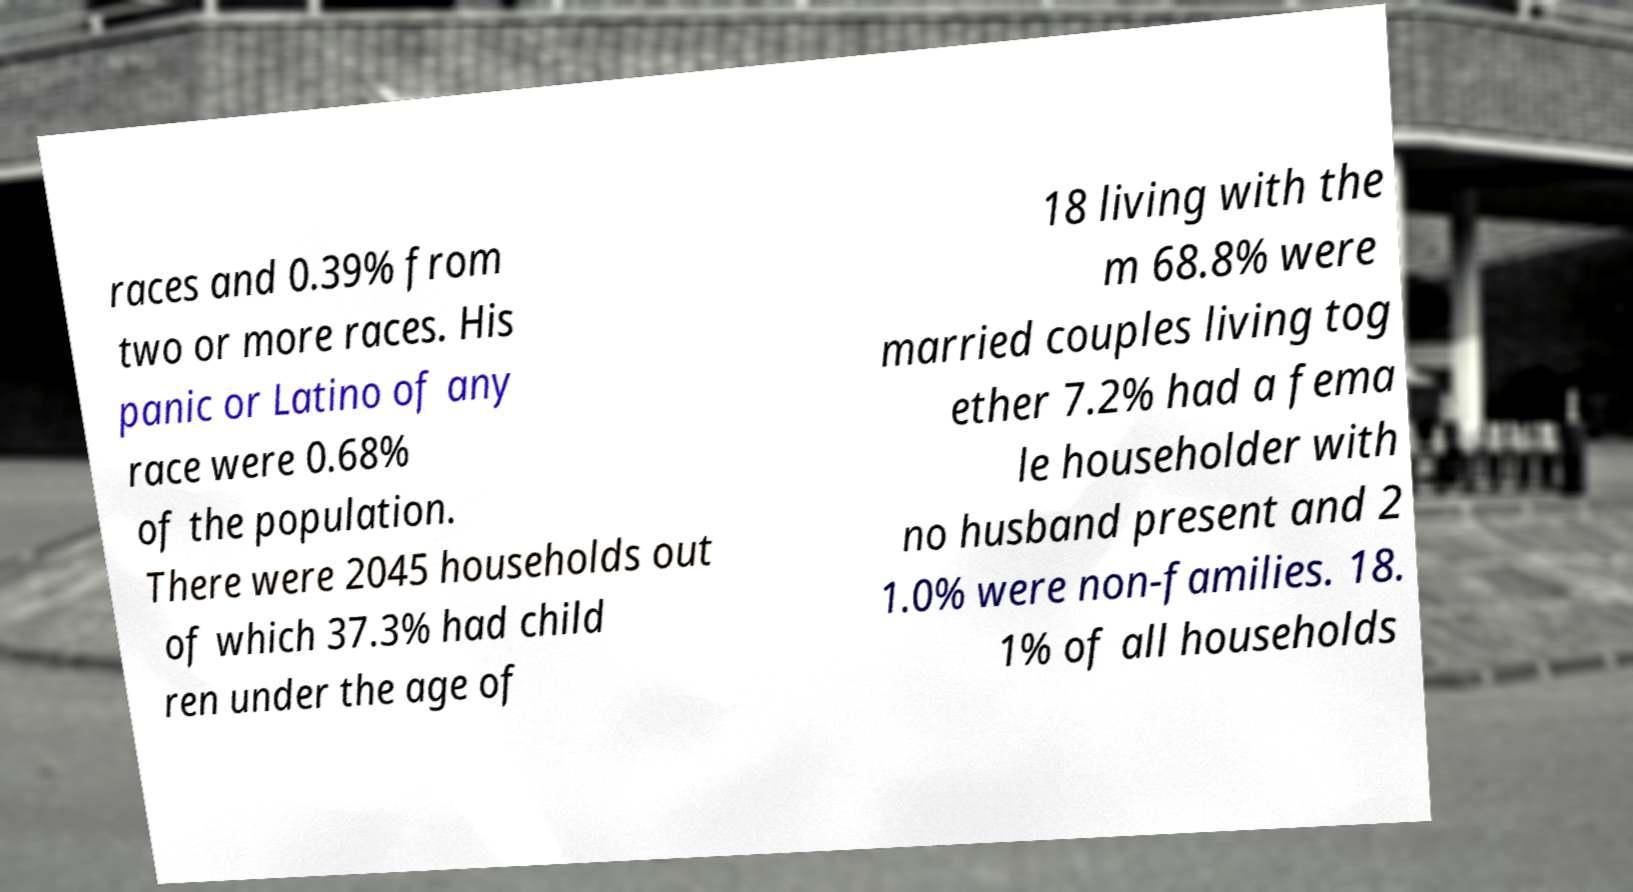For documentation purposes, I need the text within this image transcribed. Could you provide that? races and 0.39% from two or more races. His panic or Latino of any race were 0.68% of the population. There were 2045 households out of which 37.3% had child ren under the age of 18 living with the m 68.8% were married couples living tog ether 7.2% had a fema le householder with no husband present and 2 1.0% were non-families. 18. 1% of all households 